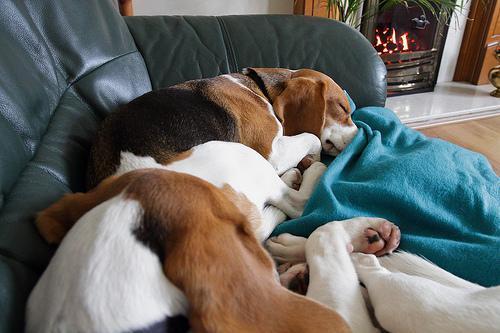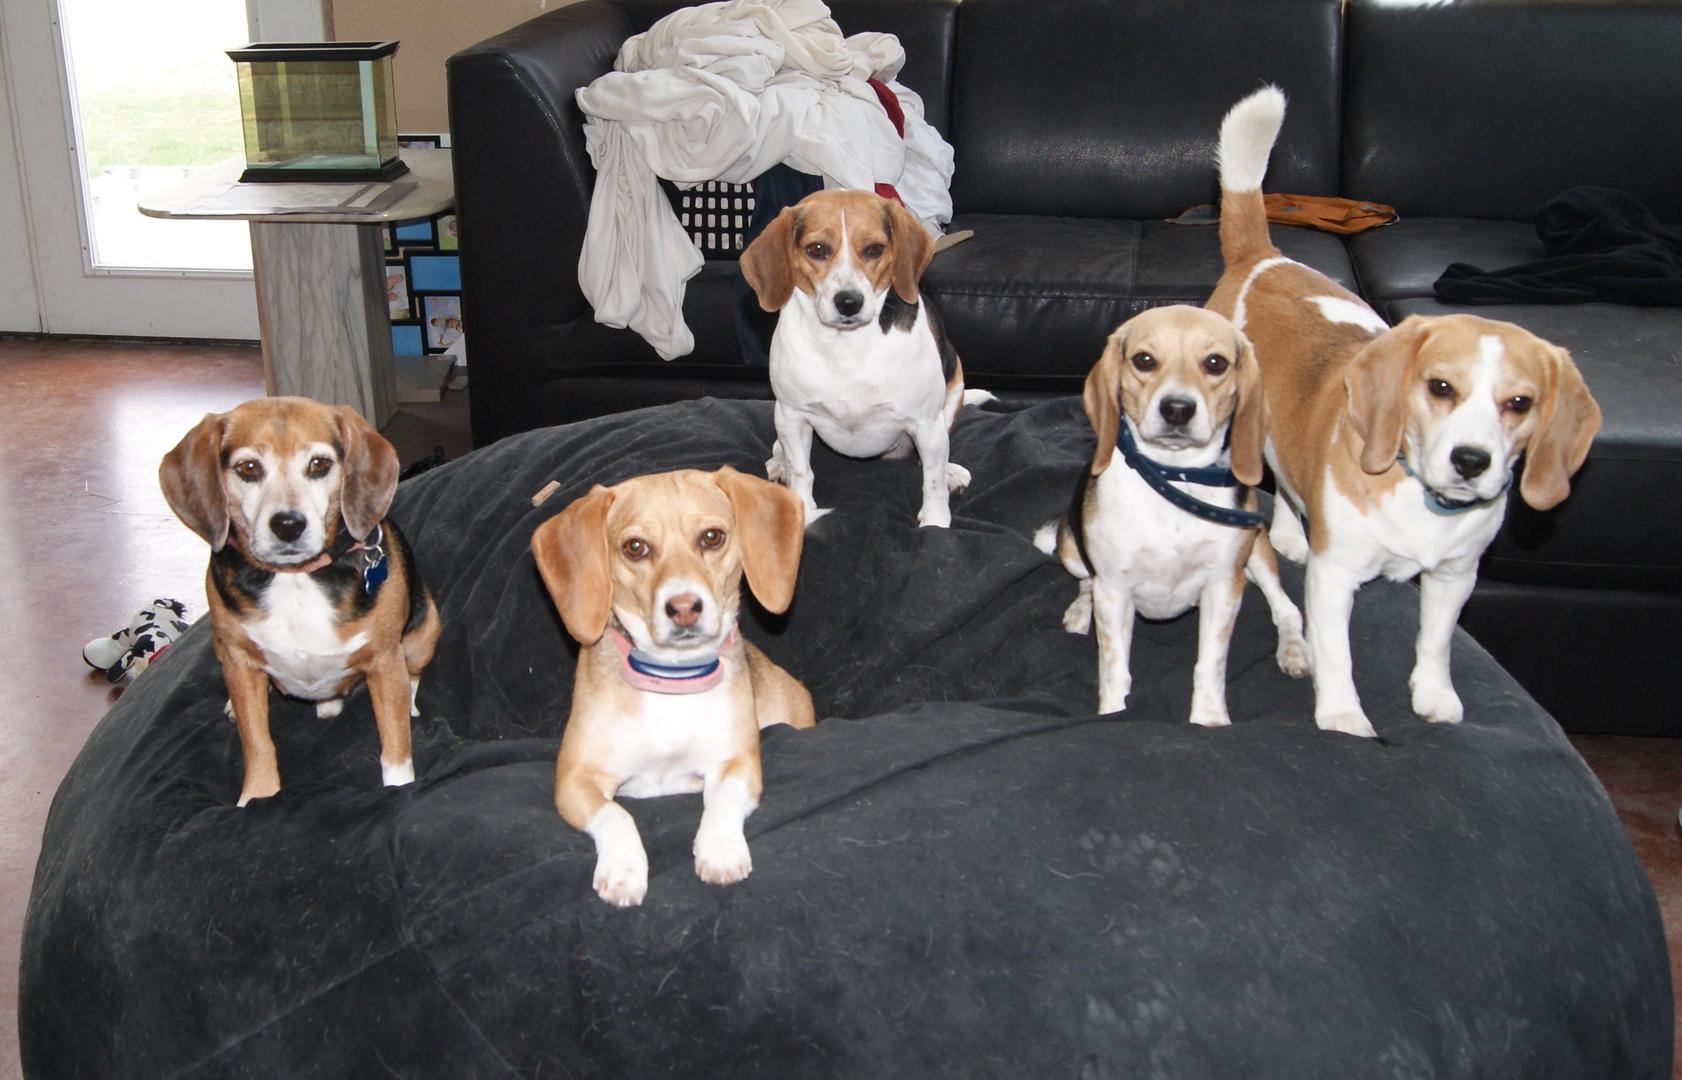The first image is the image on the left, the second image is the image on the right. Assess this claim about the two images: "There are no more than two dogs in the right image.". Correct or not? Answer yes or no. No. The first image is the image on the left, the second image is the image on the right. Analyze the images presented: Is the assertion "One image shows a beagle outdoors on grass, with its mouth next to a plastic object that is at least partly bright red." valid? Answer yes or no. No. 